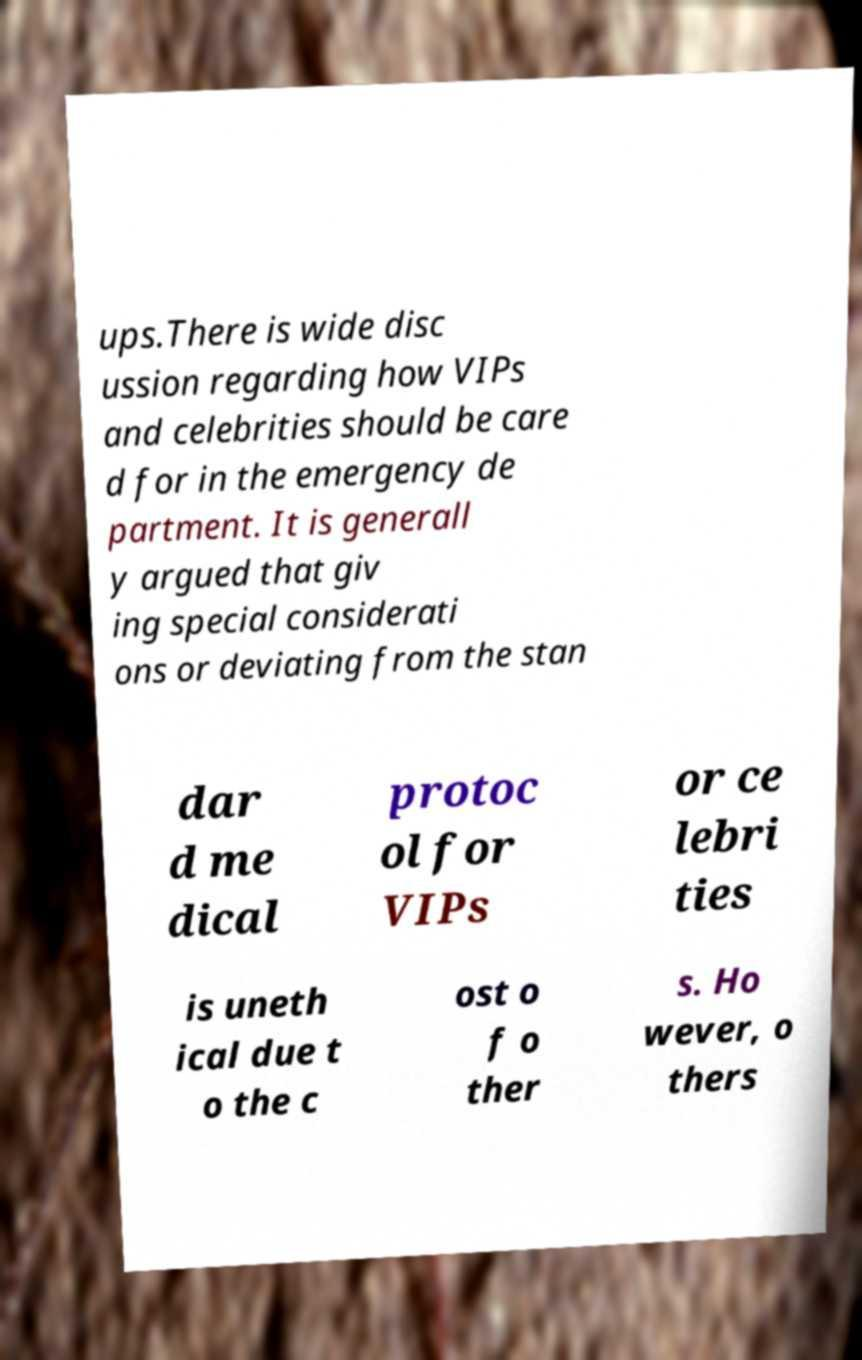I need the written content from this picture converted into text. Can you do that? ups.There is wide disc ussion regarding how VIPs and celebrities should be care d for in the emergency de partment. It is generall y argued that giv ing special considerati ons or deviating from the stan dar d me dical protoc ol for VIPs or ce lebri ties is uneth ical due t o the c ost o f o ther s. Ho wever, o thers 